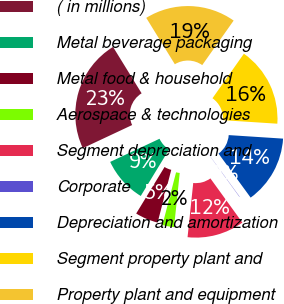Convert chart. <chart><loc_0><loc_0><loc_500><loc_500><pie_chart><fcel>( in millions)<fcel>Metal beverage packaging<fcel>Metal food & household<fcel>Aerospace & technologies<fcel>Segment depreciation and<fcel>Corporate<fcel>Depreciation and amortization<fcel>Segment property plant and<fcel>Property plant and equipment<nl><fcel>23.19%<fcel>9.31%<fcel>4.68%<fcel>2.37%<fcel>11.63%<fcel>0.06%<fcel>13.94%<fcel>16.25%<fcel>18.57%<nl></chart> 